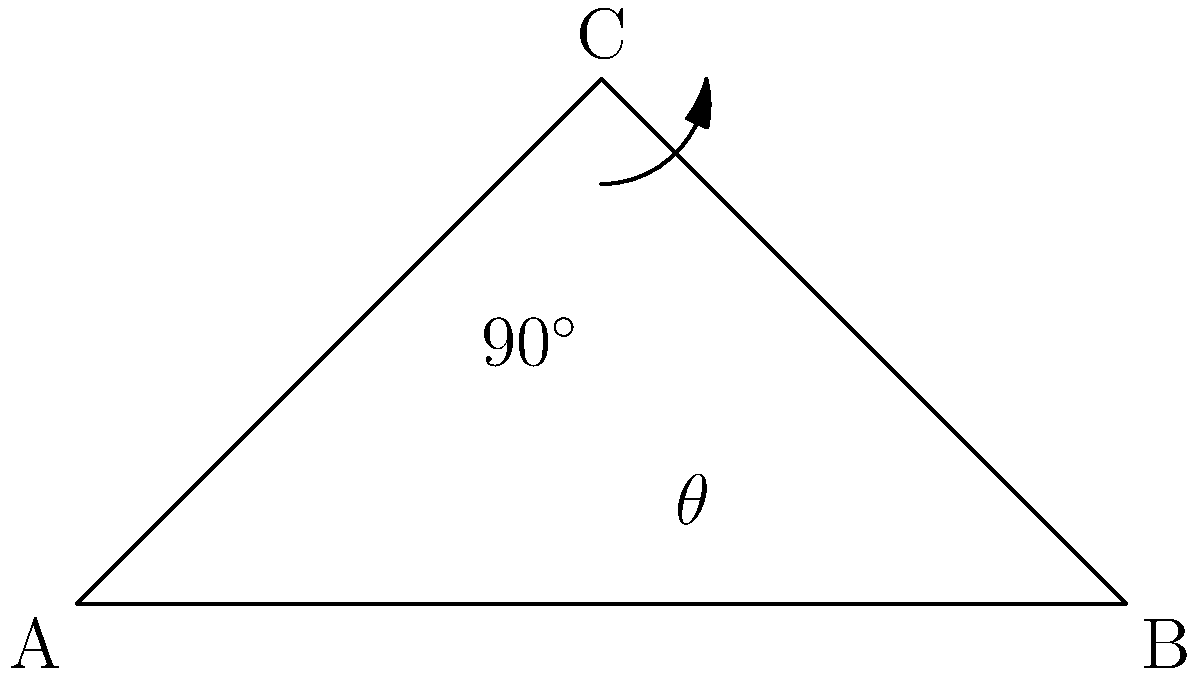In the diagram above, which represents a simplified model of a pantograph on a high-speed train, what is the optimal angle $\theta$ for the pantograph arm to maintain consistent contact with the overhead wire while minimizing wear and aerodynamic drag? To find the optimal angle for the pantograph, we need to consider the following factors:

1. Contact force: The pantograph needs to maintain consistent contact with the overhead wire.
2. Wear: Minimize wear on both the pantograph and the overhead wire.
3. Aerodynamic drag: Reduce air resistance at high speeds.

The optimal angle balances these factors:

1. A 45-degree angle provides a good balance between vertical and horizontal forces.
2. At 45 degrees, the contact force is evenly distributed, reducing wear.
3. This angle also minimizes the frontal area exposed to air flow, reducing drag.

To verify mathematically:

1. In a right-angled triangle, the 45-degree angle occurs when the two non-right angles are equal.
2. This happens when the base and height of the triangle are equal.
3. In the diagram, if angle $\theta$ is 45 degrees, triangle ABC becomes isosceles.

Therefore, the optimal angle $\theta$ for the pantograph arm is 45 degrees.
Answer: 45 degrees 